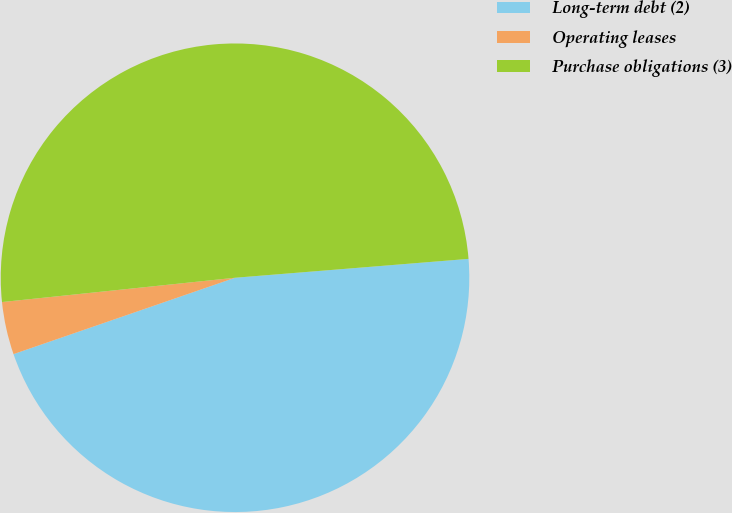Convert chart to OTSL. <chart><loc_0><loc_0><loc_500><loc_500><pie_chart><fcel>Long-term debt (2)<fcel>Operating leases<fcel>Purchase obligations (3)<nl><fcel>46.0%<fcel>3.63%<fcel>50.37%<nl></chart> 